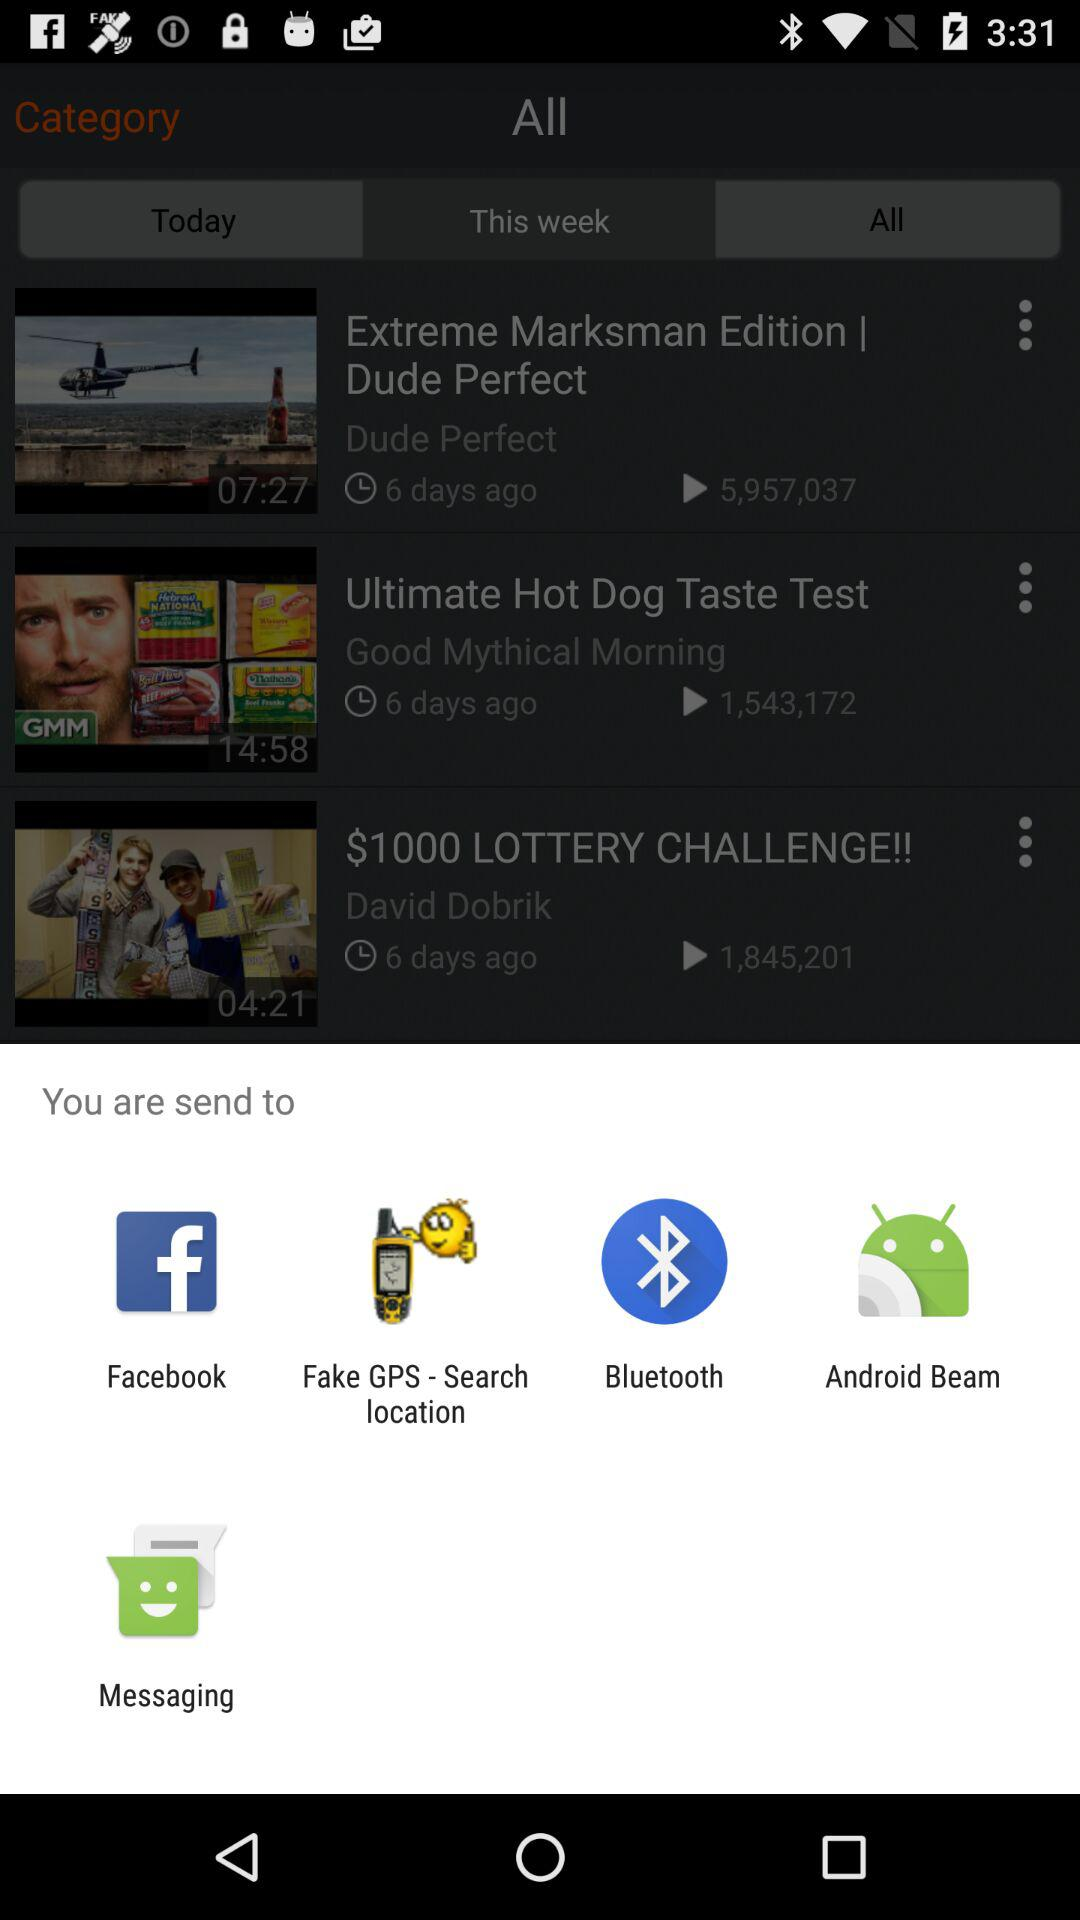What are the options available to send? The available options are "Facebook", "Fake GPS-Search location", "Bluetooth", "Android Beam", and "Messaging". 